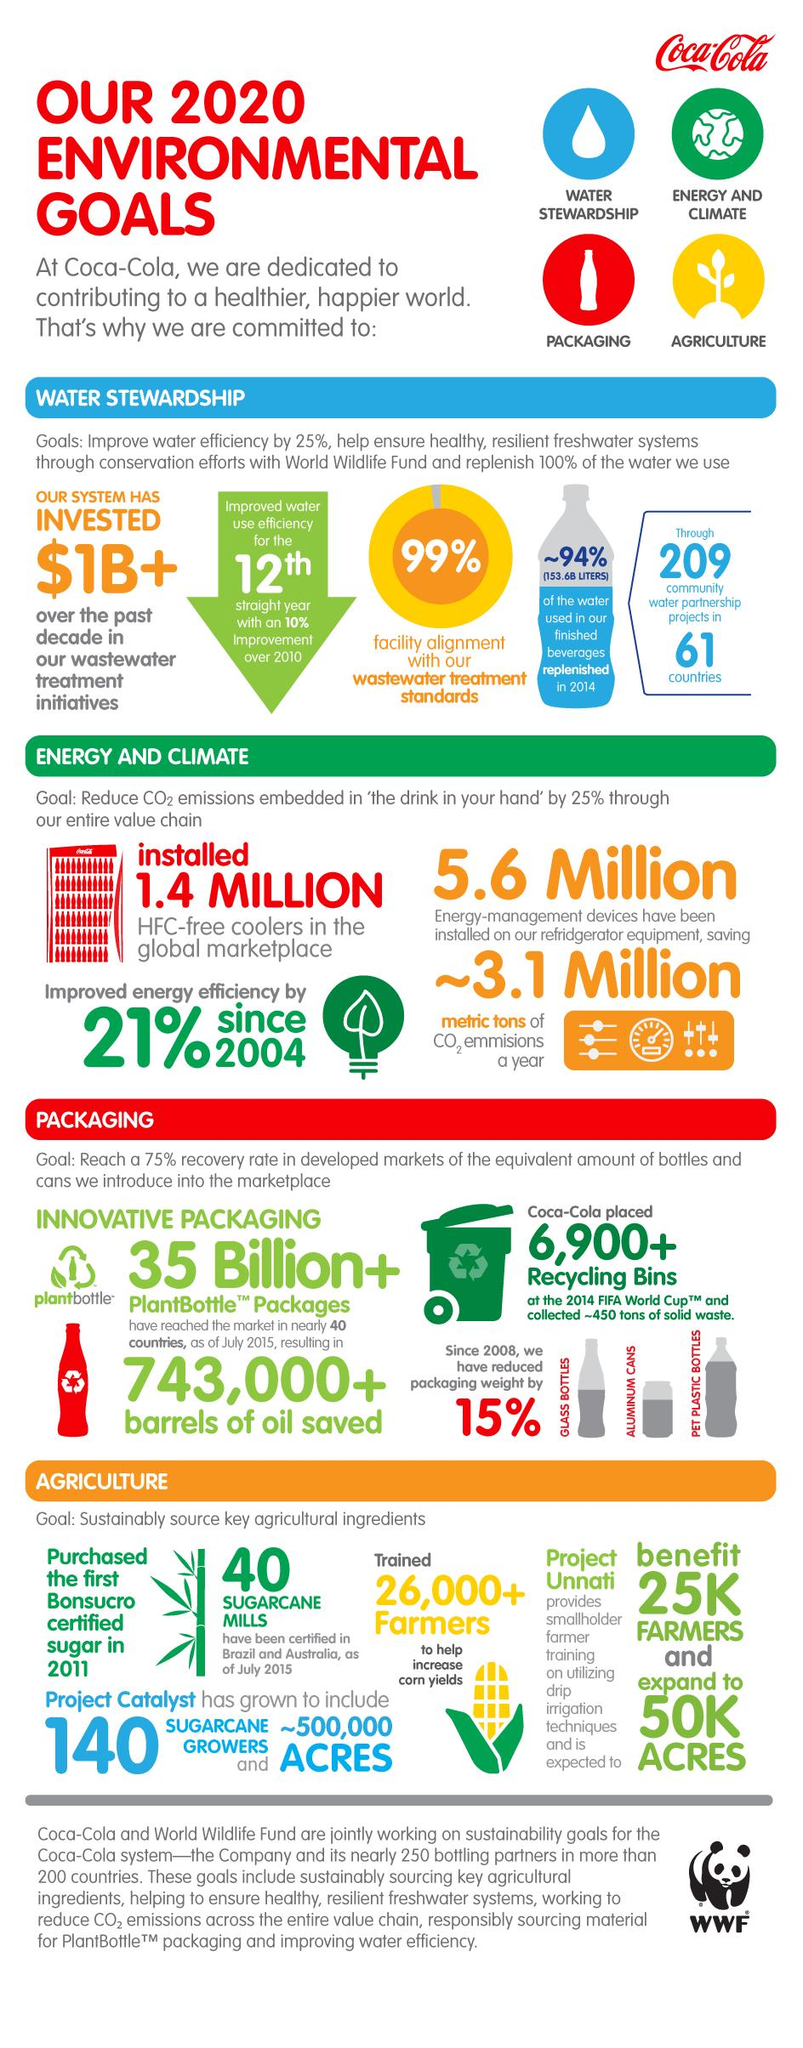List a handful of essential elements in this visual. Sugar cane mills in Australia and Brazil have been certified in the number of 40, respectively. This infographic mentions 209 water partnership projects. 